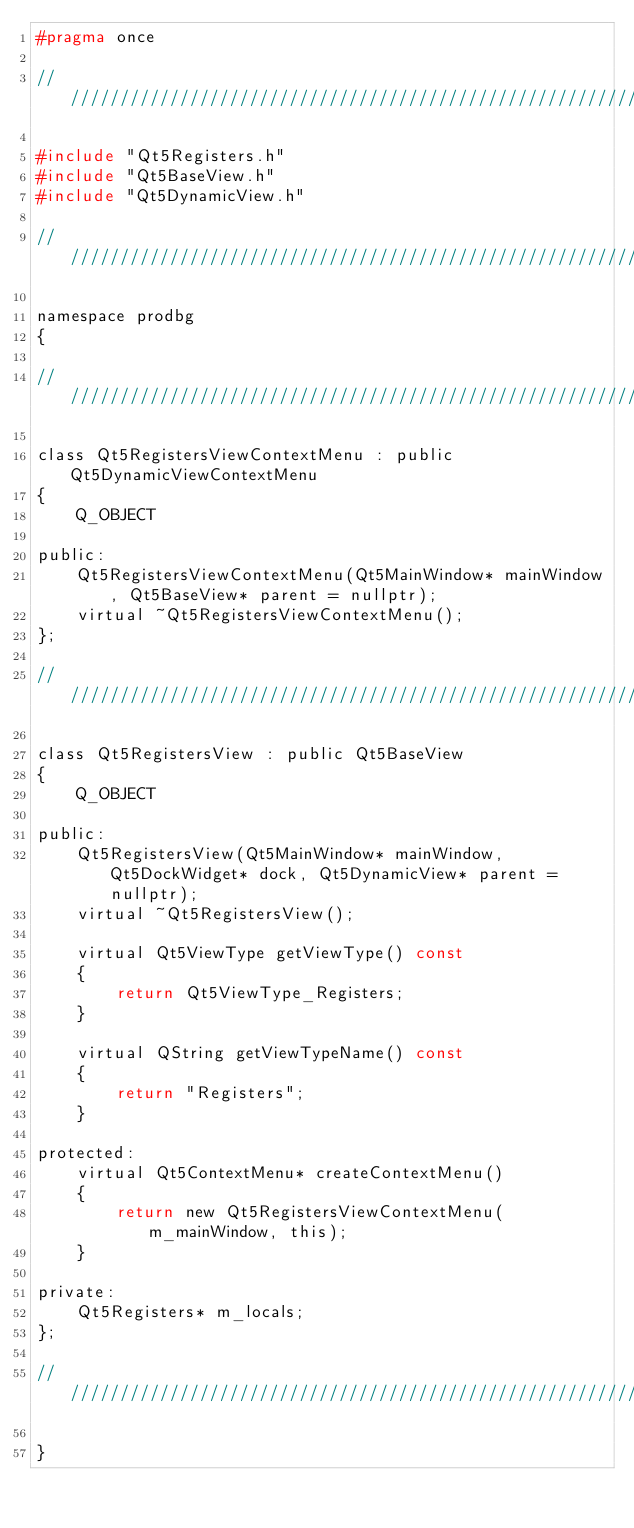<code> <loc_0><loc_0><loc_500><loc_500><_C_>#pragma once

///////////////////////////////////////////////////////////////////////////////////////////////////////////////////////

#include "Qt5Registers.h"
#include "Qt5BaseView.h"
#include "Qt5DynamicView.h"

///////////////////////////////////////////////////////////////////////////////////////////////////////////////////////

namespace prodbg
{

///////////////////////////////////////////////////////////////////////////////////////////////////////////////////////

class Qt5RegistersViewContextMenu : public Qt5DynamicViewContextMenu
{
    Q_OBJECT

public:
    Qt5RegistersViewContextMenu(Qt5MainWindow* mainWindow, Qt5BaseView* parent = nullptr);
    virtual ~Qt5RegistersViewContextMenu();
};

///////////////////////////////////////////////////////////////////////////////////////////////////////////////////////

class Qt5RegistersView : public Qt5BaseView
{
    Q_OBJECT

public:
    Qt5RegistersView(Qt5MainWindow* mainWindow, Qt5DockWidget* dock, Qt5DynamicView* parent = nullptr);
    virtual ~Qt5RegistersView();

    virtual Qt5ViewType getViewType() const
    {
        return Qt5ViewType_Registers;
    }

    virtual QString getViewTypeName() const
    {
        return "Registers";
    }

protected:
    virtual Qt5ContextMenu* createContextMenu()
    {
        return new Qt5RegistersViewContextMenu(m_mainWindow, this);
    }

private:
    Qt5Registers* m_locals;
};

///////////////////////////////////////////////////////////////////////////////////////////////////////////////////////

}
</code> 